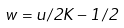Convert formula to latex. <formula><loc_0><loc_0><loc_500><loc_500>w = u / 2 K - 1 / 2</formula> 